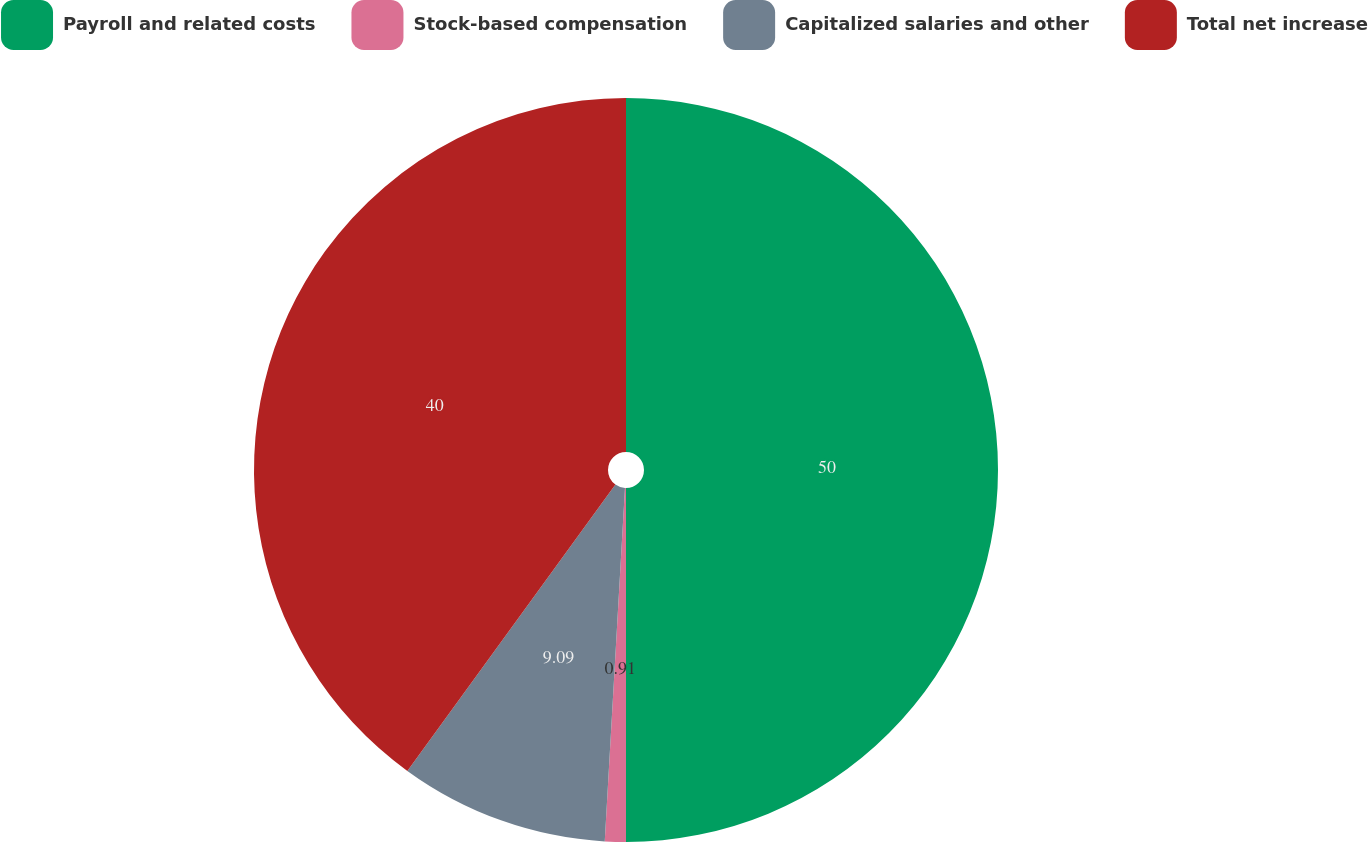Convert chart. <chart><loc_0><loc_0><loc_500><loc_500><pie_chart><fcel>Payroll and related costs<fcel>Stock-based compensation<fcel>Capitalized salaries and other<fcel>Total net increase<nl><fcel>50.0%<fcel>0.91%<fcel>9.09%<fcel>40.0%<nl></chart> 